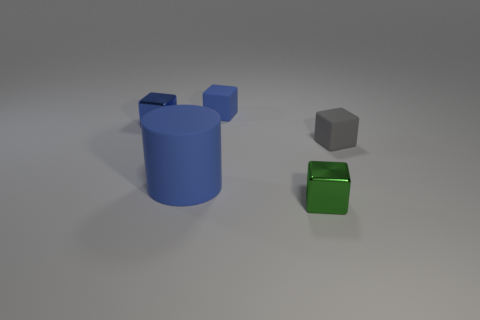How many matte objects are tiny gray cylinders or large blue cylinders? In the image, we can observe one large blue cylinder and no tiny gray cylinders. Therefore, the total count of matte objects that are either tiny gray cylinders or large blue cylinders is one. 